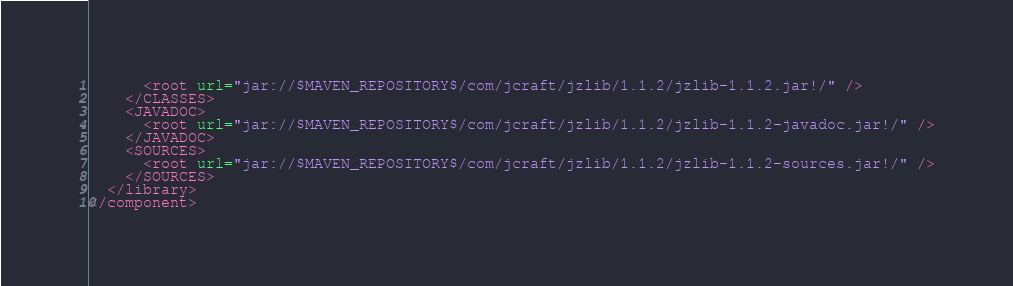<code> <loc_0><loc_0><loc_500><loc_500><_XML_>      <root url="jar://$MAVEN_REPOSITORY$/com/jcraft/jzlib/1.1.2/jzlib-1.1.2.jar!/" />
    </CLASSES>
    <JAVADOC>
      <root url="jar://$MAVEN_REPOSITORY$/com/jcraft/jzlib/1.1.2/jzlib-1.1.2-javadoc.jar!/" />
    </JAVADOC>
    <SOURCES>
      <root url="jar://$MAVEN_REPOSITORY$/com/jcraft/jzlib/1.1.2/jzlib-1.1.2-sources.jar!/" />
    </SOURCES>
  </library>
</component></code> 